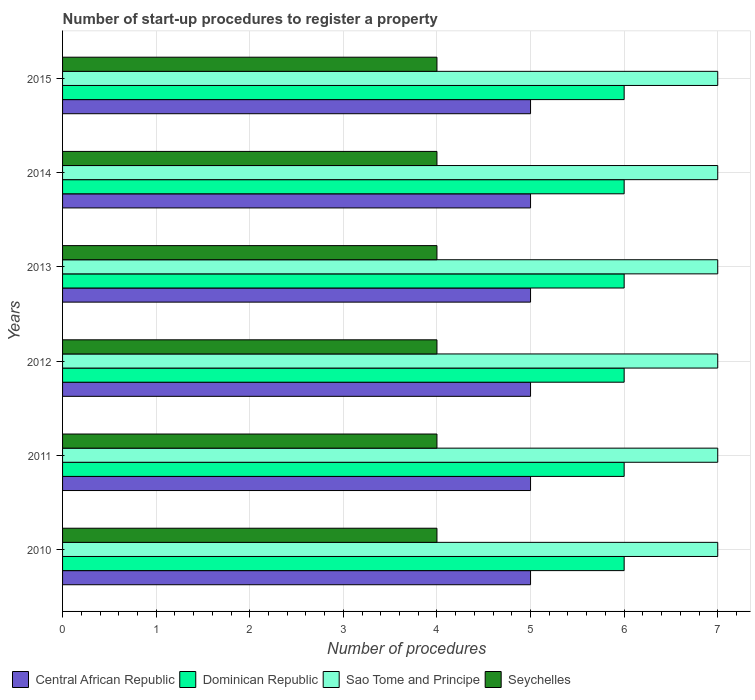How many different coloured bars are there?
Keep it short and to the point. 4. How many groups of bars are there?
Your answer should be compact. 6. Are the number of bars on each tick of the Y-axis equal?
Give a very brief answer. Yes. What is the label of the 1st group of bars from the top?
Keep it short and to the point. 2015. In which year was the number of procedures required to register a property in Seychelles minimum?
Your response must be concise. 2010. What is the total number of procedures required to register a property in Sao Tome and Principe in the graph?
Provide a succinct answer. 42. What is the difference between the number of procedures required to register a property in Dominican Republic in 2014 and that in 2015?
Provide a succinct answer. 0. What is the difference between the number of procedures required to register a property in Sao Tome and Principe in 2010 and the number of procedures required to register a property in Dominican Republic in 2015?
Give a very brief answer. 1. What is the average number of procedures required to register a property in Dominican Republic per year?
Keep it short and to the point. 6. In how many years, is the number of procedures required to register a property in Central African Republic greater than 0.6000000000000001 ?
Provide a short and direct response. 6. What is the ratio of the number of procedures required to register a property in Central African Republic in 2011 to that in 2015?
Your answer should be compact. 1. What is the difference between the highest and the lowest number of procedures required to register a property in Dominican Republic?
Provide a short and direct response. 0. Is it the case that in every year, the sum of the number of procedures required to register a property in Seychelles and number of procedures required to register a property in Dominican Republic is greater than the sum of number of procedures required to register a property in Central African Republic and number of procedures required to register a property in Sao Tome and Principe?
Provide a succinct answer. Yes. What does the 1st bar from the top in 2013 represents?
Provide a succinct answer. Seychelles. What does the 3rd bar from the bottom in 2014 represents?
Offer a very short reply. Sao Tome and Principe. Is it the case that in every year, the sum of the number of procedures required to register a property in Sao Tome and Principe and number of procedures required to register a property in Seychelles is greater than the number of procedures required to register a property in Central African Republic?
Make the answer very short. Yes. Are all the bars in the graph horizontal?
Keep it short and to the point. Yes. How many years are there in the graph?
Keep it short and to the point. 6. Does the graph contain grids?
Provide a succinct answer. Yes. Where does the legend appear in the graph?
Make the answer very short. Bottom left. How many legend labels are there?
Make the answer very short. 4. How are the legend labels stacked?
Make the answer very short. Horizontal. What is the title of the graph?
Offer a very short reply. Number of start-up procedures to register a property. Does "United States" appear as one of the legend labels in the graph?
Your answer should be very brief. No. What is the label or title of the X-axis?
Give a very brief answer. Number of procedures. What is the Number of procedures in Central African Republic in 2010?
Provide a succinct answer. 5. What is the Number of procedures in Seychelles in 2010?
Your answer should be compact. 4. What is the Number of procedures in Dominican Republic in 2011?
Your answer should be very brief. 6. What is the Number of procedures in Sao Tome and Principe in 2011?
Ensure brevity in your answer.  7. What is the Number of procedures in Seychelles in 2011?
Your answer should be compact. 4. What is the Number of procedures in Central African Republic in 2012?
Make the answer very short. 5. What is the Number of procedures of Dominican Republic in 2012?
Provide a succinct answer. 6. What is the Number of procedures of Seychelles in 2012?
Offer a very short reply. 4. What is the Number of procedures of Central African Republic in 2013?
Provide a succinct answer. 5. What is the Number of procedures in Dominican Republic in 2013?
Keep it short and to the point. 6. What is the Number of procedures of Seychelles in 2013?
Keep it short and to the point. 4. What is the Number of procedures of Sao Tome and Principe in 2014?
Make the answer very short. 7. What is the Number of procedures in Central African Republic in 2015?
Give a very brief answer. 5. What is the Number of procedures in Dominican Republic in 2015?
Your answer should be very brief. 6. What is the Number of procedures of Sao Tome and Principe in 2015?
Keep it short and to the point. 7. What is the Number of procedures in Seychelles in 2015?
Your answer should be compact. 4. Across all years, what is the maximum Number of procedures in Dominican Republic?
Make the answer very short. 6. Across all years, what is the minimum Number of procedures in Central African Republic?
Offer a terse response. 5. Across all years, what is the minimum Number of procedures in Dominican Republic?
Make the answer very short. 6. Across all years, what is the minimum Number of procedures in Sao Tome and Principe?
Provide a short and direct response. 7. What is the total Number of procedures of Central African Republic in the graph?
Offer a very short reply. 30. What is the total Number of procedures in Dominican Republic in the graph?
Keep it short and to the point. 36. What is the total Number of procedures in Sao Tome and Principe in the graph?
Give a very brief answer. 42. What is the total Number of procedures in Seychelles in the graph?
Your answer should be very brief. 24. What is the difference between the Number of procedures in Central African Republic in 2010 and that in 2011?
Your answer should be compact. 0. What is the difference between the Number of procedures in Dominican Republic in 2010 and that in 2011?
Offer a very short reply. 0. What is the difference between the Number of procedures in Seychelles in 2010 and that in 2011?
Offer a very short reply. 0. What is the difference between the Number of procedures of Dominican Republic in 2010 and that in 2012?
Ensure brevity in your answer.  0. What is the difference between the Number of procedures in Sao Tome and Principe in 2010 and that in 2012?
Your answer should be compact. 0. What is the difference between the Number of procedures of Central African Republic in 2010 and that in 2013?
Keep it short and to the point. 0. What is the difference between the Number of procedures in Sao Tome and Principe in 2010 and that in 2013?
Provide a succinct answer. 0. What is the difference between the Number of procedures of Seychelles in 2010 and that in 2013?
Provide a short and direct response. 0. What is the difference between the Number of procedures of Central African Republic in 2010 and that in 2014?
Provide a succinct answer. 0. What is the difference between the Number of procedures in Seychelles in 2010 and that in 2014?
Provide a short and direct response. 0. What is the difference between the Number of procedures in Central African Republic in 2010 and that in 2015?
Ensure brevity in your answer.  0. What is the difference between the Number of procedures of Dominican Republic in 2010 and that in 2015?
Offer a terse response. 0. What is the difference between the Number of procedures in Seychelles in 2010 and that in 2015?
Your response must be concise. 0. What is the difference between the Number of procedures in Central African Republic in 2011 and that in 2012?
Give a very brief answer. 0. What is the difference between the Number of procedures of Dominican Republic in 2011 and that in 2012?
Give a very brief answer. 0. What is the difference between the Number of procedures in Seychelles in 2011 and that in 2012?
Make the answer very short. 0. What is the difference between the Number of procedures in Central African Republic in 2011 and that in 2013?
Provide a short and direct response. 0. What is the difference between the Number of procedures in Sao Tome and Principe in 2011 and that in 2015?
Provide a short and direct response. 0. What is the difference between the Number of procedures of Central African Republic in 2012 and that in 2013?
Your response must be concise. 0. What is the difference between the Number of procedures in Sao Tome and Principe in 2012 and that in 2013?
Provide a short and direct response. 0. What is the difference between the Number of procedures of Seychelles in 2012 and that in 2013?
Make the answer very short. 0. What is the difference between the Number of procedures of Central African Republic in 2012 and that in 2014?
Give a very brief answer. 0. What is the difference between the Number of procedures in Sao Tome and Principe in 2012 and that in 2014?
Offer a terse response. 0. What is the difference between the Number of procedures in Seychelles in 2012 and that in 2014?
Offer a terse response. 0. What is the difference between the Number of procedures of Sao Tome and Principe in 2012 and that in 2015?
Ensure brevity in your answer.  0. What is the difference between the Number of procedures in Seychelles in 2012 and that in 2015?
Your answer should be very brief. 0. What is the difference between the Number of procedures of Central African Republic in 2013 and that in 2014?
Provide a succinct answer. 0. What is the difference between the Number of procedures of Sao Tome and Principe in 2013 and that in 2014?
Your response must be concise. 0. What is the difference between the Number of procedures in Dominican Republic in 2013 and that in 2015?
Your answer should be very brief. 0. What is the difference between the Number of procedures in Seychelles in 2013 and that in 2015?
Ensure brevity in your answer.  0. What is the difference between the Number of procedures in Central African Republic in 2010 and the Number of procedures in Sao Tome and Principe in 2011?
Your answer should be compact. -2. What is the difference between the Number of procedures of Dominican Republic in 2010 and the Number of procedures of Seychelles in 2011?
Your answer should be compact. 2. What is the difference between the Number of procedures of Central African Republic in 2010 and the Number of procedures of Sao Tome and Principe in 2012?
Your response must be concise. -2. What is the difference between the Number of procedures of Dominican Republic in 2010 and the Number of procedures of Seychelles in 2012?
Your answer should be compact. 2. What is the difference between the Number of procedures in Sao Tome and Principe in 2010 and the Number of procedures in Seychelles in 2012?
Your response must be concise. 3. What is the difference between the Number of procedures of Central African Republic in 2010 and the Number of procedures of Seychelles in 2013?
Your answer should be very brief. 1. What is the difference between the Number of procedures in Dominican Republic in 2010 and the Number of procedures in Sao Tome and Principe in 2014?
Provide a short and direct response. -1. What is the difference between the Number of procedures of Sao Tome and Principe in 2010 and the Number of procedures of Seychelles in 2014?
Ensure brevity in your answer.  3. What is the difference between the Number of procedures in Central African Republic in 2010 and the Number of procedures in Sao Tome and Principe in 2015?
Keep it short and to the point. -2. What is the difference between the Number of procedures in Central African Republic in 2010 and the Number of procedures in Seychelles in 2015?
Provide a short and direct response. 1. What is the difference between the Number of procedures in Central African Republic in 2011 and the Number of procedures in Seychelles in 2012?
Your answer should be compact. 1. What is the difference between the Number of procedures of Dominican Republic in 2011 and the Number of procedures of Seychelles in 2012?
Offer a very short reply. 2. What is the difference between the Number of procedures of Sao Tome and Principe in 2011 and the Number of procedures of Seychelles in 2012?
Offer a very short reply. 3. What is the difference between the Number of procedures in Central African Republic in 2011 and the Number of procedures in Sao Tome and Principe in 2013?
Offer a very short reply. -2. What is the difference between the Number of procedures in Central African Republic in 2011 and the Number of procedures in Dominican Republic in 2014?
Your response must be concise. -1. What is the difference between the Number of procedures of Central African Republic in 2011 and the Number of procedures of Seychelles in 2014?
Give a very brief answer. 1. What is the difference between the Number of procedures in Dominican Republic in 2011 and the Number of procedures in Sao Tome and Principe in 2014?
Offer a very short reply. -1. What is the difference between the Number of procedures of Dominican Republic in 2011 and the Number of procedures of Seychelles in 2014?
Make the answer very short. 2. What is the difference between the Number of procedures of Sao Tome and Principe in 2011 and the Number of procedures of Seychelles in 2014?
Provide a short and direct response. 3. What is the difference between the Number of procedures of Central African Republic in 2011 and the Number of procedures of Sao Tome and Principe in 2015?
Keep it short and to the point. -2. What is the difference between the Number of procedures in Central African Republic in 2012 and the Number of procedures in Seychelles in 2013?
Make the answer very short. 1. What is the difference between the Number of procedures of Sao Tome and Principe in 2012 and the Number of procedures of Seychelles in 2013?
Your response must be concise. 3. What is the difference between the Number of procedures in Central African Republic in 2012 and the Number of procedures in Seychelles in 2014?
Your answer should be compact. 1. What is the difference between the Number of procedures of Dominican Republic in 2012 and the Number of procedures of Sao Tome and Principe in 2014?
Offer a terse response. -1. What is the difference between the Number of procedures in Dominican Republic in 2012 and the Number of procedures in Seychelles in 2014?
Provide a succinct answer. 2. What is the difference between the Number of procedures of Sao Tome and Principe in 2012 and the Number of procedures of Seychelles in 2014?
Give a very brief answer. 3. What is the difference between the Number of procedures in Central African Republic in 2012 and the Number of procedures in Sao Tome and Principe in 2015?
Provide a short and direct response. -2. What is the difference between the Number of procedures in Dominican Republic in 2012 and the Number of procedures in Seychelles in 2015?
Offer a very short reply. 2. What is the difference between the Number of procedures in Sao Tome and Principe in 2012 and the Number of procedures in Seychelles in 2015?
Provide a succinct answer. 3. What is the difference between the Number of procedures in Central African Republic in 2013 and the Number of procedures in Dominican Republic in 2014?
Keep it short and to the point. -1. What is the difference between the Number of procedures in Central African Republic in 2013 and the Number of procedures in Seychelles in 2014?
Provide a short and direct response. 1. What is the difference between the Number of procedures in Dominican Republic in 2013 and the Number of procedures in Sao Tome and Principe in 2014?
Offer a very short reply. -1. What is the difference between the Number of procedures in Central African Republic in 2013 and the Number of procedures in Sao Tome and Principe in 2015?
Offer a very short reply. -2. What is the difference between the Number of procedures in Dominican Republic in 2013 and the Number of procedures in Sao Tome and Principe in 2015?
Your answer should be very brief. -1. What is the difference between the Number of procedures in Dominican Republic in 2013 and the Number of procedures in Seychelles in 2015?
Your response must be concise. 2. What is the difference between the Number of procedures of Central African Republic in 2014 and the Number of procedures of Dominican Republic in 2015?
Keep it short and to the point. -1. What is the difference between the Number of procedures in Central African Republic in 2014 and the Number of procedures in Sao Tome and Principe in 2015?
Your response must be concise. -2. What is the difference between the Number of procedures in Sao Tome and Principe in 2014 and the Number of procedures in Seychelles in 2015?
Give a very brief answer. 3. What is the average Number of procedures of Central African Republic per year?
Your response must be concise. 5. What is the average Number of procedures of Dominican Republic per year?
Give a very brief answer. 6. What is the average Number of procedures of Sao Tome and Principe per year?
Provide a short and direct response. 7. In the year 2010, what is the difference between the Number of procedures in Central African Republic and Number of procedures in Seychelles?
Keep it short and to the point. 1. In the year 2010, what is the difference between the Number of procedures in Dominican Republic and Number of procedures in Seychelles?
Your answer should be very brief. 2. In the year 2011, what is the difference between the Number of procedures of Central African Republic and Number of procedures of Dominican Republic?
Offer a terse response. -1. In the year 2011, what is the difference between the Number of procedures of Central African Republic and Number of procedures of Sao Tome and Principe?
Ensure brevity in your answer.  -2. In the year 2011, what is the difference between the Number of procedures in Central African Republic and Number of procedures in Seychelles?
Your answer should be very brief. 1. In the year 2011, what is the difference between the Number of procedures of Dominican Republic and Number of procedures of Sao Tome and Principe?
Your response must be concise. -1. In the year 2011, what is the difference between the Number of procedures of Sao Tome and Principe and Number of procedures of Seychelles?
Give a very brief answer. 3. In the year 2012, what is the difference between the Number of procedures of Central African Republic and Number of procedures of Dominican Republic?
Give a very brief answer. -1. In the year 2012, what is the difference between the Number of procedures of Central African Republic and Number of procedures of Seychelles?
Ensure brevity in your answer.  1. In the year 2012, what is the difference between the Number of procedures in Dominican Republic and Number of procedures in Sao Tome and Principe?
Provide a succinct answer. -1. In the year 2013, what is the difference between the Number of procedures of Central African Republic and Number of procedures of Dominican Republic?
Offer a terse response. -1. In the year 2013, what is the difference between the Number of procedures in Central African Republic and Number of procedures in Sao Tome and Principe?
Provide a short and direct response. -2. In the year 2013, what is the difference between the Number of procedures in Central African Republic and Number of procedures in Seychelles?
Offer a very short reply. 1. In the year 2013, what is the difference between the Number of procedures of Dominican Republic and Number of procedures of Seychelles?
Offer a very short reply. 2. In the year 2013, what is the difference between the Number of procedures in Sao Tome and Principe and Number of procedures in Seychelles?
Your answer should be compact. 3. In the year 2014, what is the difference between the Number of procedures in Central African Republic and Number of procedures in Sao Tome and Principe?
Offer a very short reply. -2. In the year 2014, what is the difference between the Number of procedures in Dominican Republic and Number of procedures in Seychelles?
Your answer should be compact. 2. In the year 2014, what is the difference between the Number of procedures in Sao Tome and Principe and Number of procedures in Seychelles?
Provide a succinct answer. 3. In the year 2015, what is the difference between the Number of procedures in Central African Republic and Number of procedures in Dominican Republic?
Your answer should be very brief. -1. In the year 2015, what is the difference between the Number of procedures in Central African Republic and Number of procedures in Sao Tome and Principe?
Give a very brief answer. -2. In the year 2015, what is the difference between the Number of procedures in Dominican Republic and Number of procedures in Sao Tome and Principe?
Make the answer very short. -1. In the year 2015, what is the difference between the Number of procedures of Dominican Republic and Number of procedures of Seychelles?
Make the answer very short. 2. What is the ratio of the Number of procedures of Central African Republic in 2010 to that in 2011?
Ensure brevity in your answer.  1. What is the ratio of the Number of procedures of Dominican Republic in 2010 to that in 2011?
Provide a short and direct response. 1. What is the ratio of the Number of procedures of Sao Tome and Principe in 2010 to that in 2011?
Offer a very short reply. 1. What is the ratio of the Number of procedures of Seychelles in 2010 to that in 2011?
Make the answer very short. 1. What is the ratio of the Number of procedures of Central African Republic in 2010 to that in 2013?
Make the answer very short. 1. What is the ratio of the Number of procedures in Seychelles in 2010 to that in 2013?
Provide a succinct answer. 1. What is the ratio of the Number of procedures of Central African Republic in 2010 to that in 2014?
Provide a succinct answer. 1. What is the ratio of the Number of procedures in Seychelles in 2010 to that in 2015?
Provide a short and direct response. 1. What is the ratio of the Number of procedures in Central African Republic in 2011 to that in 2012?
Offer a very short reply. 1. What is the ratio of the Number of procedures in Dominican Republic in 2011 to that in 2013?
Ensure brevity in your answer.  1. What is the ratio of the Number of procedures in Sao Tome and Principe in 2011 to that in 2014?
Keep it short and to the point. 1. What is the ratio of the Number of procedures of Central African Republic in 2011 to that in 2015?
Keep it short and to the point. 1. What is the ratio of the Number of procedures of Sao Tome and Principe in 2011 to that in 2015?
Provide a short and direct response. 1. What is the ratio of the Number of procedures in Seychelles in 2011 to that in 2015?
Your response must be concise. 1. What is the ratio of the Number of procedures in Central African Republic in 2012 to that in 2013?
Your answer should be very brief. 1. What is the ratio of the Number of procedures in Dominican Republic in 2012 to that in 2014?
Your response must be concise. 1. What is the ratio of the Number of procedures of Seychelles in 2012 to that in 2014?
Provide a succinct answer. 1. What is the ratio of the Number of procedures in Central African Republic in 2012 to that in 2015?
Your response must be concise. 1. What is the ratio of the Number of procedures in Dominican Republic in 2012 to that in 2015?
Provide a short and direct response. 1. What is the ratio of the Number of procedures of Sao Tome and Principe in 2012 to that in 2015?
Provide a succinct answer. 1. What is the ratio of the Number of procedures in Dominican Republic in 2013 to that in 2014?
Ensure brevity in your answer.  1. What is the ratio of the Number of procedures in Sao Tome and Principe in 2013 to that in 2014?
Keep it short and to the point. 1. What is the ratio of the Number of procedures in Seychelles in 2013 to that in 2014?
Ensure brevity in your answer.  1. What is the ratio of the Number of procedures in Dominican Republic in 2013 to that in 2015?
Ensure brevity in your answer.  1. What is the ratio of the Number of procedures of Seychelles in 2013 to that in 2015?
Offer a terse response. 1. What is the ratio of the Number of procedures in Central African Republic in 2014 to that in 2015?
Make the answer very short. 1. What is the ratio of the Number of procedures in Dominican Republic in 2014 to that in 2015?
Your answer should be very brief. 1. What is the difference between the highest and the second highest Number of procedures of Central African Republic?
Provide a short and direct response. 0. What is the difference between the highest and the second highest Number of procedures of Seychelles?
Your answer should be very brief. 0. What is the difference between the highest and the lowest Number of procedures in Central African Republic?
Make the answer very short. 0. What is the difference between the highest and the lowest Number of procedures of Dominican Republic?
Your answer should be compact. 0. What is the difference between the highest and the lowest Number of procedures of Sao Tome and Principe?
Make the answer very short. 0. 